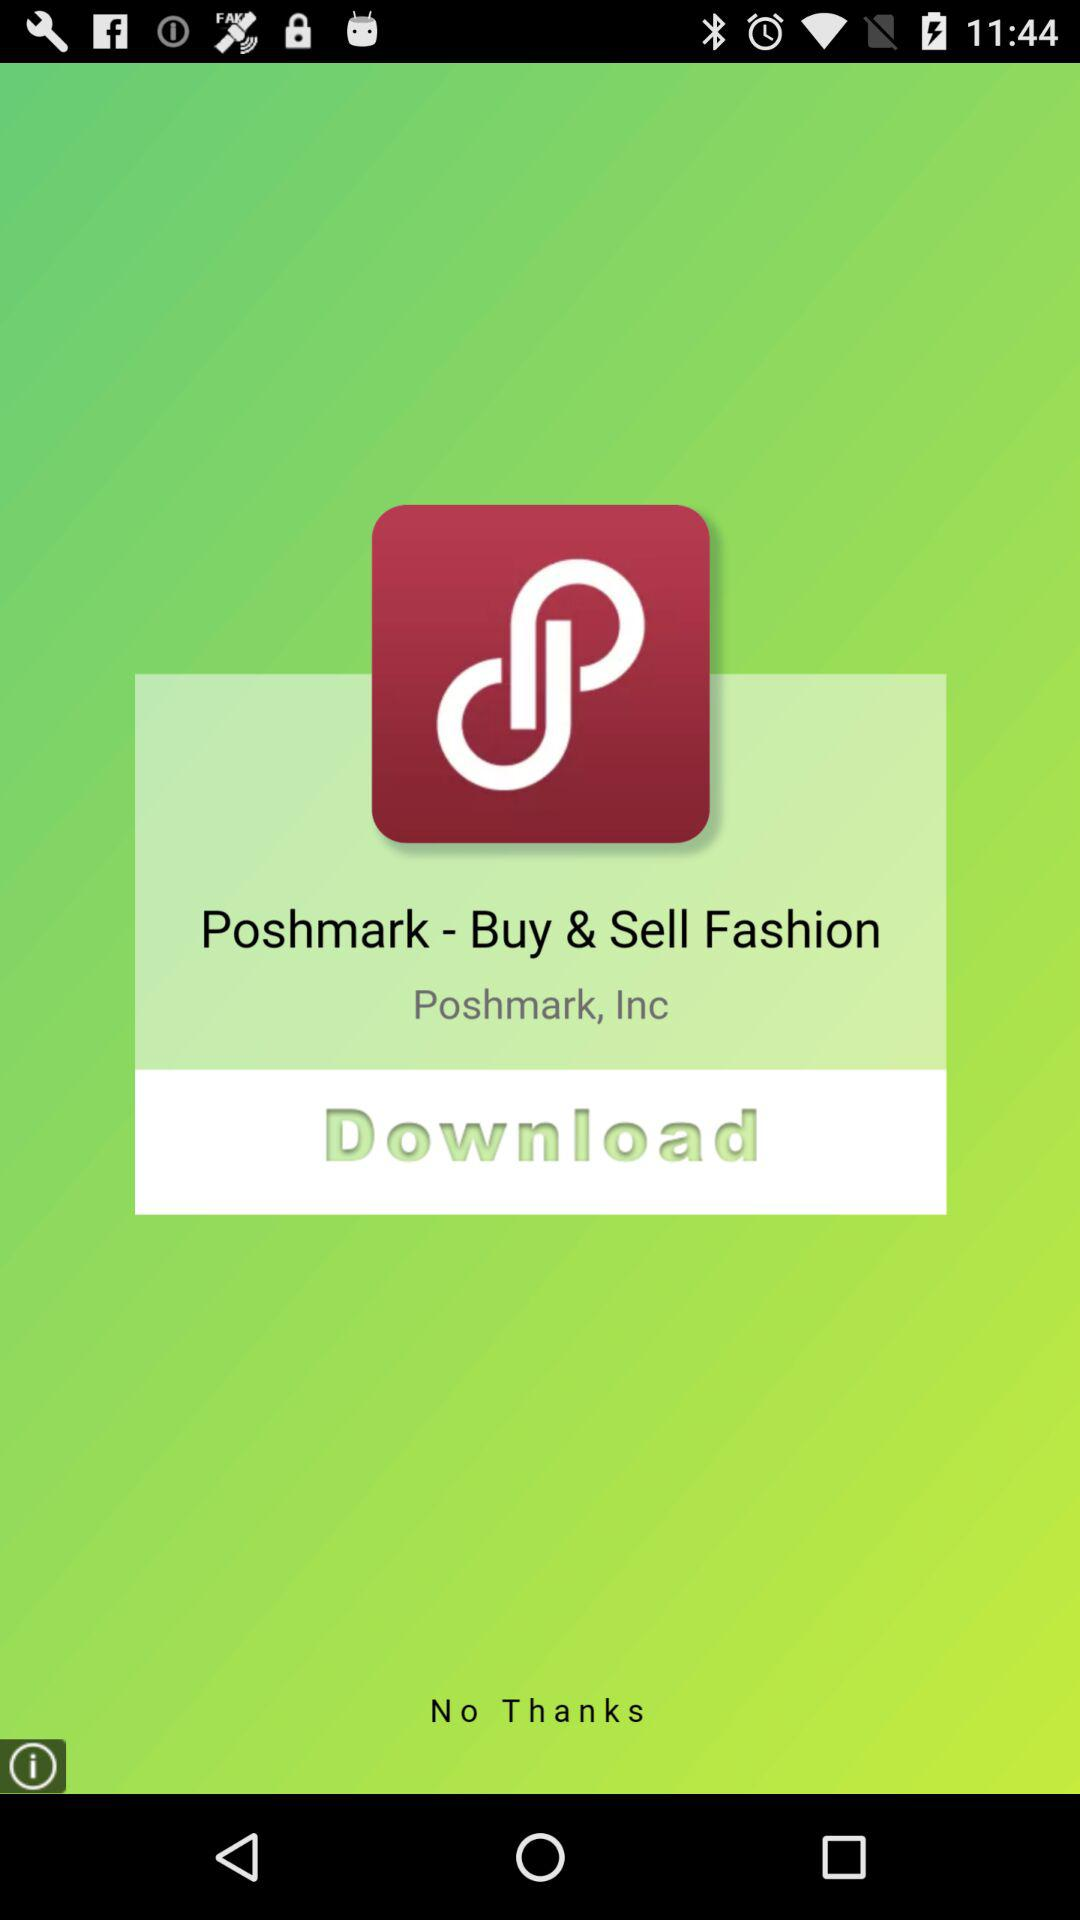What is the name of the application? The name of the application is "Poshmark - Buy & Sell Fashion". 